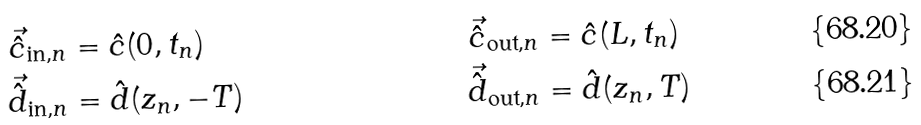<formula> <loc_0><loc_0><loc_500><loc_500>\vec { \hat { c } } _ { \text {in} , n } & = \hat { c } ( 0 , t _ { n } ) & \vec { \hat { c } } _ { \text {out} , n } & = \hat { c } ( L , t _ { n } ) \\ \vec { \hat { d } } _ { \text {in} , n } & = \hat { d } ( z _ { n } , - T ) & \vec { \hat { d } } _ { \text {out} , n } & = \hat { d } ( z _ { n } , T )</formula> 